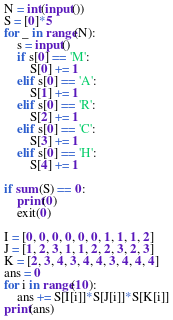<code> <loc_0><loc_0><loc_500><loc_500><_Python_>N = int(input())
S = [0]*5
for _ in range(N):
    s = input()
    if s[0] == 'M':
        S[0] += 1
    elif s[0] == 'A':
        S[1] += 1
    elif s[0] == 'R':
        S[2] += 1
    elif s[0] == 'C':
        S[3] += 1
    elif s[0] == 'H':
        S[4] += 1

if sum(S) == 0:
    print(0)
    exit(0)

I = [0, 0, 0, 0, 0, 0, 1, 1, 1, 2]
J = [1, 2, 3, 1, 1, 2, 2, 3, 2, 3]
K = [2, 3, 4, 3, 4, 4, 3, 4, 4, 4]
ans = 0
for i in range(10):
    ans += S[I[i]]*S[J[i]]*S[K[i]]
print(ans)
</code> 